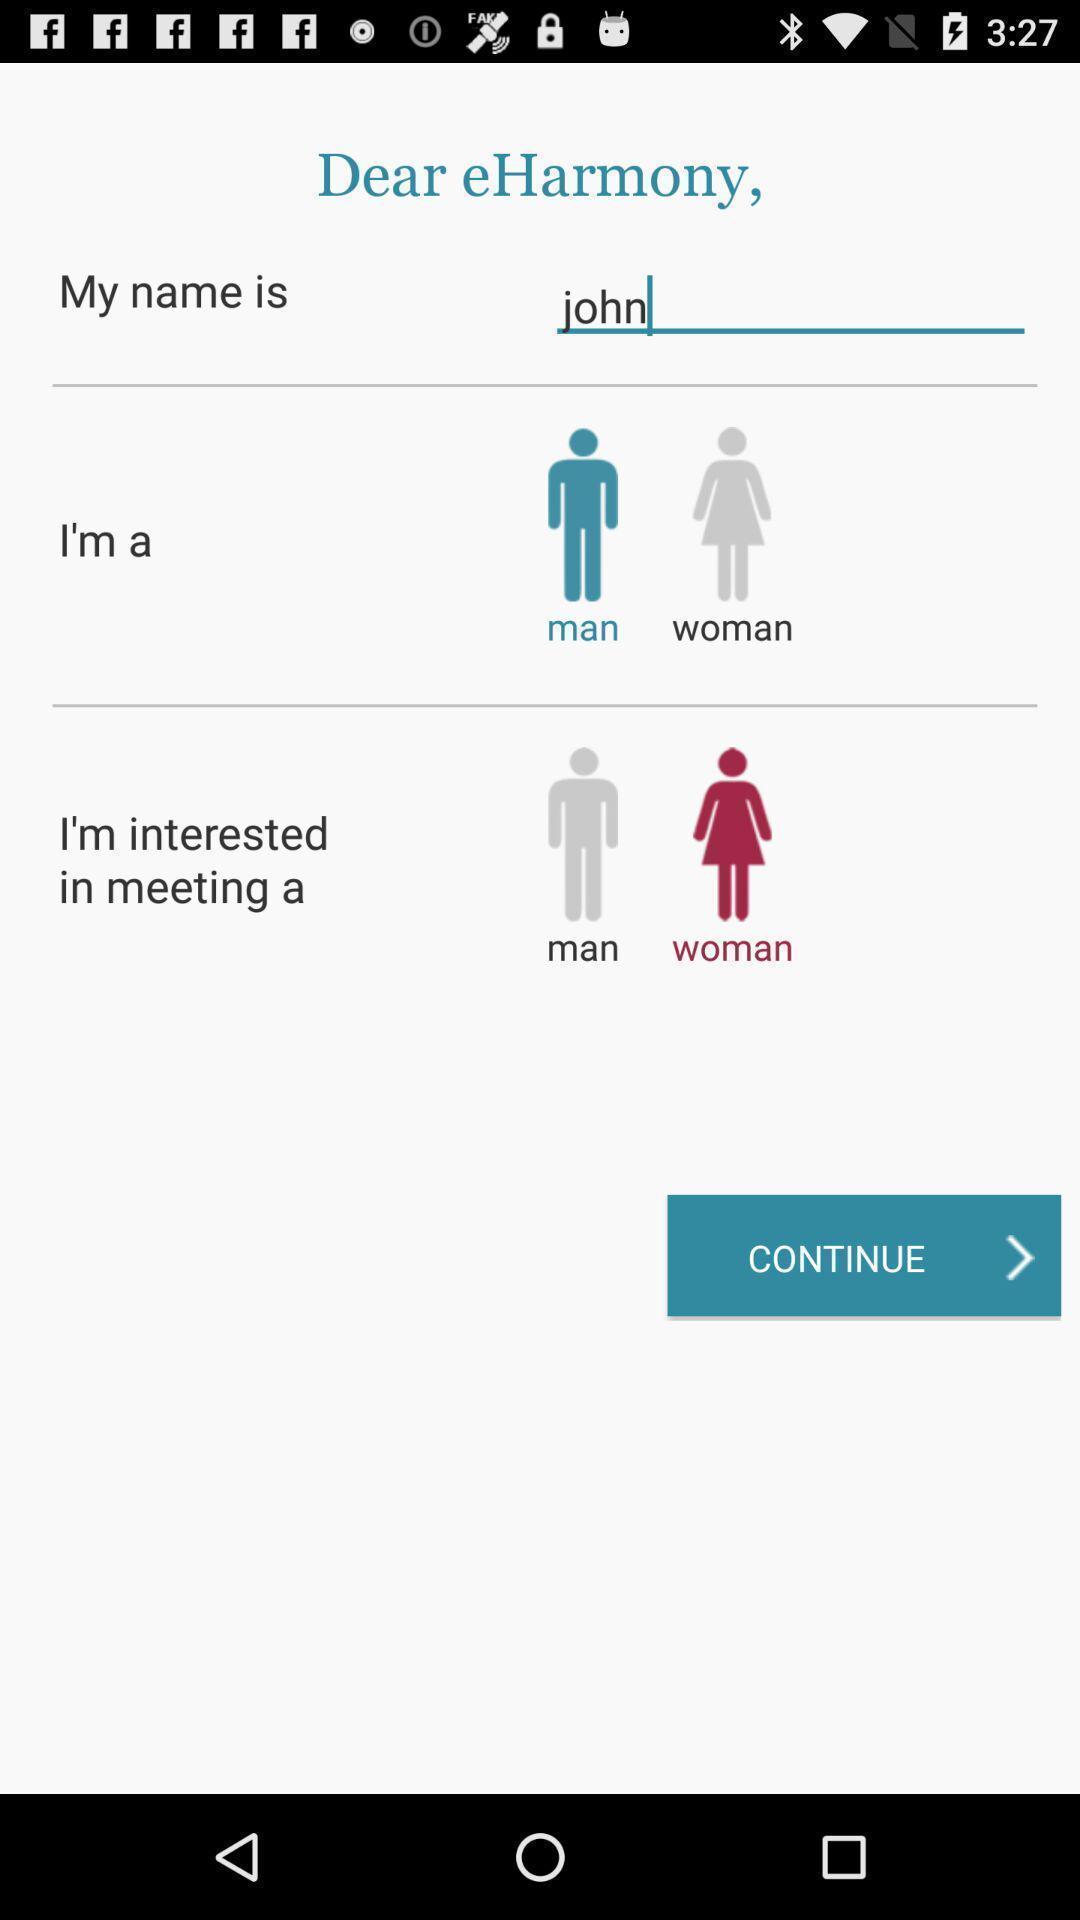Give me a summary of this screen capture. Window displaying a connecting app. 